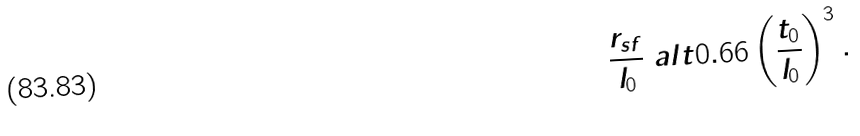<formula> <loc_0><loc_0><loc_500><loc_500>\frac { r _ { s f } } { l _ { 0 } } \ a l t 0 . 6 6 \left ( \frac { t _ { 0 } } { l _ { 0 } } \right ) ^ { 3 } .</formula> 